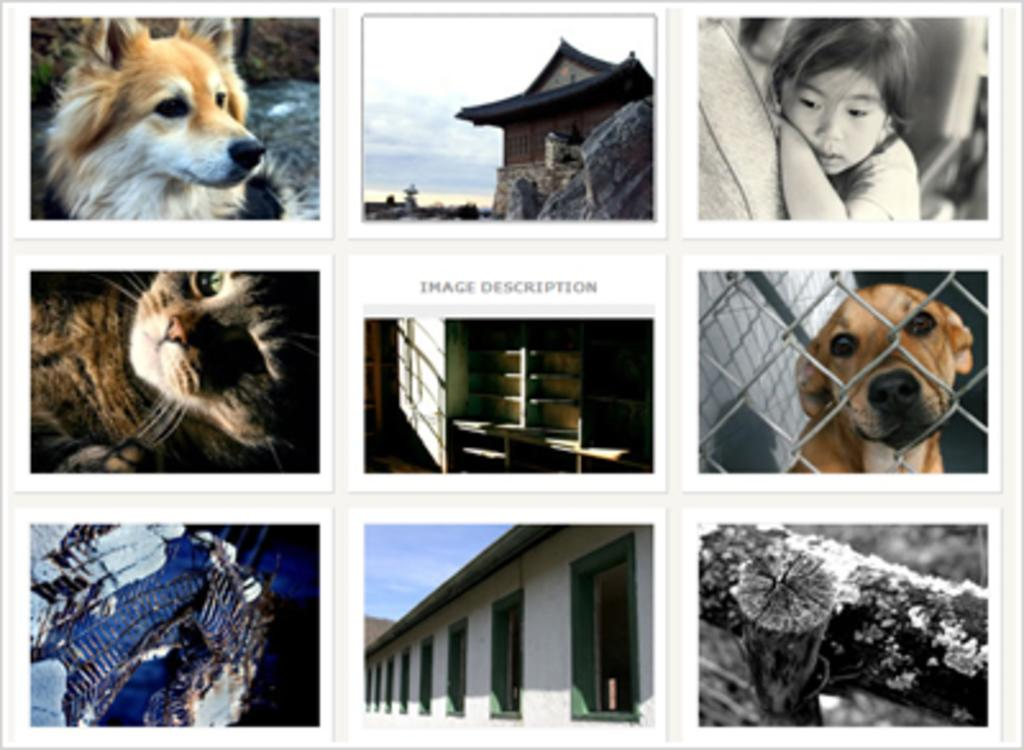What type of animals can be seen in the collage? There are dogs and a cat in the collage. What other elements are present in the collage besides animals? There are buildings, a girl, the sky, a shelf, and a log in the collage. Can you describe the setting of the collage? The collage features a mix of indoor and outdoor elements, including buildings, a sky, and a log. What might the girl be doing in the collage? It is not clear what the girl is doing in the collage, but she is present among the other elements. What type of star can be seen in the collage? There is no star present in the collage; it features a sky, but not a celestial object like a star. 